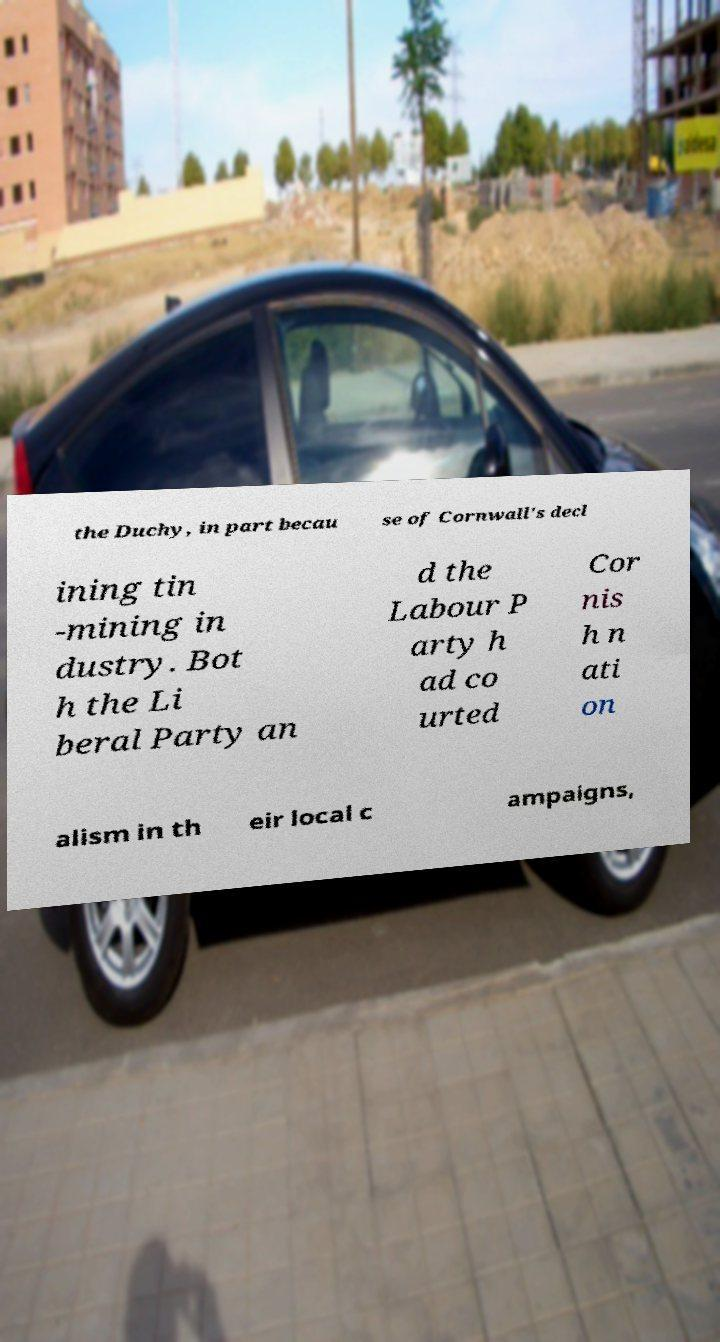For documentation purposes, I need the text within this image transcribed. Could you provide that? the Duchy, in part becau se of Cornwall's decl ining tin -mining in dustry. Bot h the Li beral Party an d the Labour P arty h ad co urted Cor nis h n ati on alism in th eir local c ampaigns, 